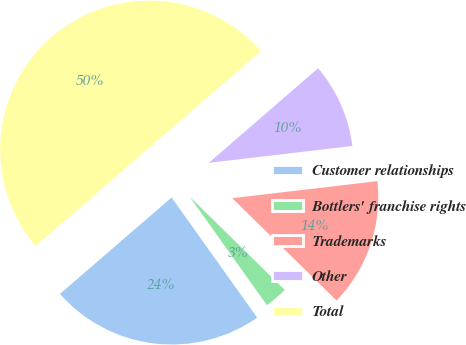Convert chart to OTSL. <chart><loc_0><loc_0><loc_500><loc_500><pie_chart><fcel>Customer relationships<fcel>Bottlers' franchise rights<fcel>Trademarks<fcel>Other<fcel>Total<nl><fcel>23.51%<fcel>2.8%<fcel>14.21%<fcel>9.5%<fcel>49.98%<nl></chart> 